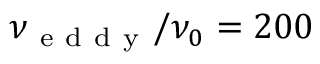Convert formula to latex. <formula><loc_0><loc_0><loc_500><loc_500>\nu _ { e d d y } / \nu _ { 0 } = 2 0 0</formula> 